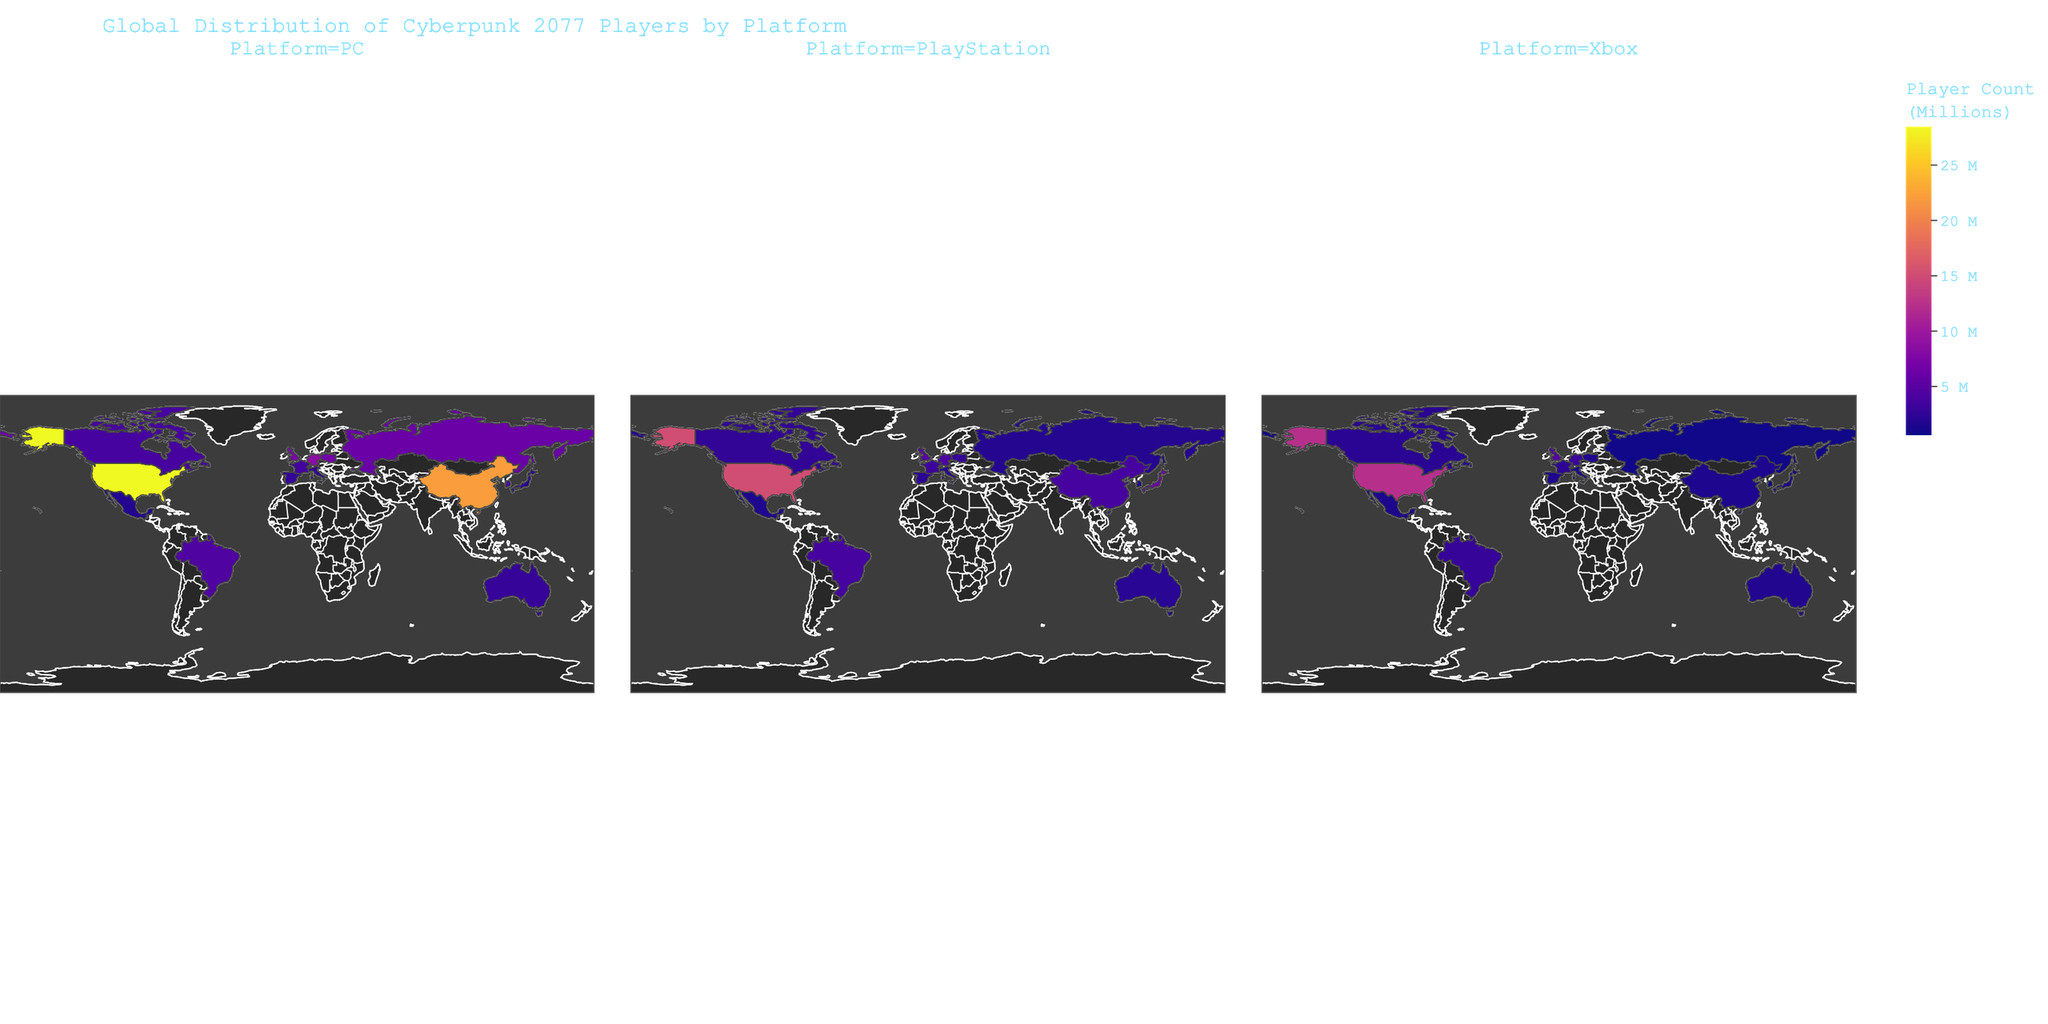What is the title of the figure? The title is typically positioned at the top of the figure and describes the main focus of the plot.
Answer: "Global Distribution of Cyberpunk 2077 Players by Platform" Which country has the highest number of Cyberpunk 2077 players on PC? By looking at the 'PC' facet, the country with the darkest color represents the highest number of players.
Answer: United States Which platform has the highest number of players in Japan? By examining the color intensity in Japan across all platform facets, the darkest color indicates the platform with the highest number of players.
Answer: PlayStation How does the number of players in Brazil compare between PC and Xbox platforms? Compare the color intensity for Brazil in both the 'PC' and 'Xbox' facets. Brazil has a darker color for PC than Xbox, indicating more players on PC than Xbox.
Answer: PC has more players What is the sum of Cyberpunk 2077 players in the United Kingdom across all platforms? Adding up the numbers for PC (7.3), PlayStation (5.1), and Xbox (4.6) gives 7.3 + 5.1 + 4.6 = 17.
Answer: 17 million Which country has the fewest players on the Xbox platform? Identify the country with the lightest color in the 'Xbox' facet. Russia has the lightest color, indicating it has the fewest players.
Answer: Russia Compare the total number of players in Poland and Canada for the PlayStation platform. Which country has more? For Poland, the number is 2.8, and for Canada, it's 2.6. Therefore, Poland has more players.
Answer: Poland What is the average number of PlayStation players among the top three countries with the highest PC players? The top three countries for PC players are the United States (15.2), China (3.8), and Germany (4.2). The average is (15.2 + 3.8 + 4.2) / 3 = 7.73.
Answer: 7.73 million Which platform has the least significant difference in players between the United States and China? Calcualte the difference for each platform: PC (28.5 - 22.1 = 6.4), PlayStation (15.2 - 3.8 = 11.4), Xbox (12.3 - 1.5 = 10.8). The smallest difference is in PC.
Answer: PC Which country has the closest number of players on Xbox to that of Italy on PlayStation? Italy on PlayStation is 2.0. By looking at the 'Xbox' facet, Canada has an Xbox value closest to 2.0, which is 2.2.
Answer: Canada 